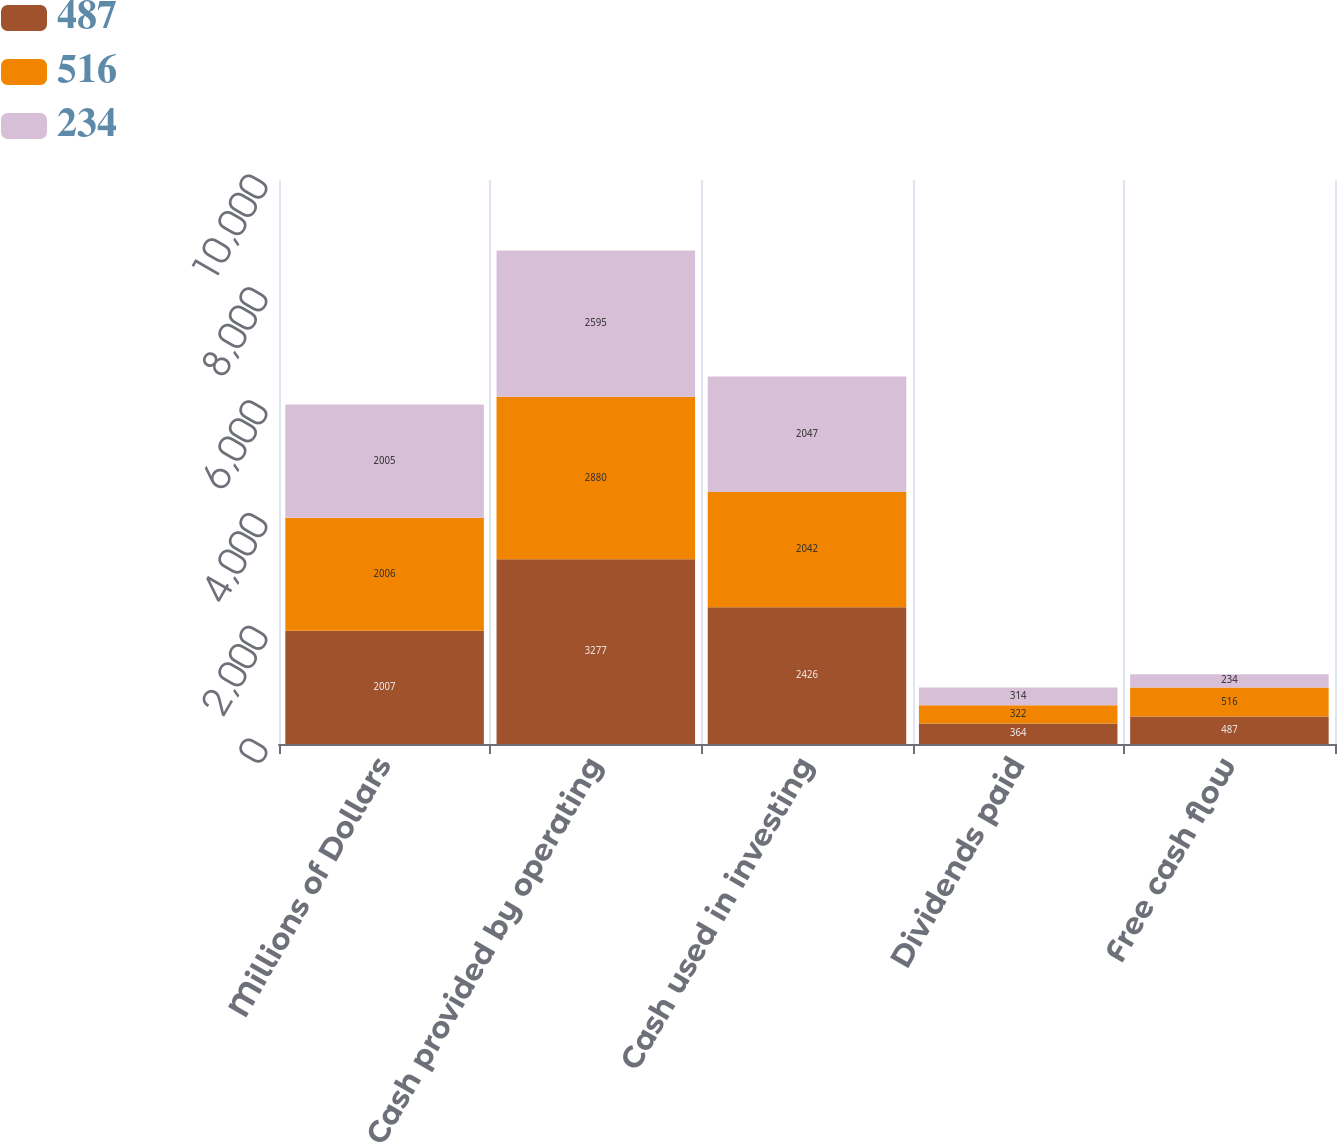Convert chart. <chart><loc_0><loc_0><loc_500><loc_500><stacked_bar_chart><ecel><fcel>Millions of Dollars<fcel>Cash provided by operating<fcel>Cash used in investing<fcel>Dividends paid<fcel>Free cash flow<nl><fcel>487<fcel>2007<fcel>3277<fcel>2426<fcel>364<fcel>487<nl><fcel>516<fcel>2006<fcel>2880<fcel>2042<fcel>322<fcel>516<nl><fcel>234<fcel>2005<fcel>2595<fcel>2047<fcel>314<fcel>234<nl></chart> 